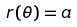Convert formula to latex. <formula><loc_0><loc_0><loc_500><loc_500>r ( \theta ) = a</formula> 